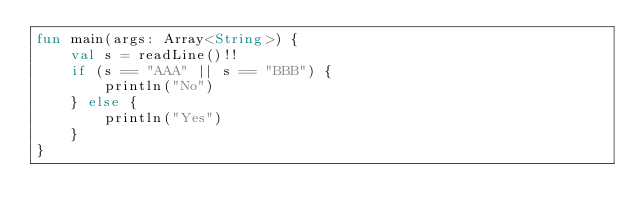Convert code to text. <code><loc_0><loc_0><loc_500><loc_500><_Kotlin_>fun main(args: Array<String>) {
    val s = readLine()!!
    if (s == "AAA" || s == "BBB") {
        println("No")
    } else {
        println("Yes")
    }
}
</code> 